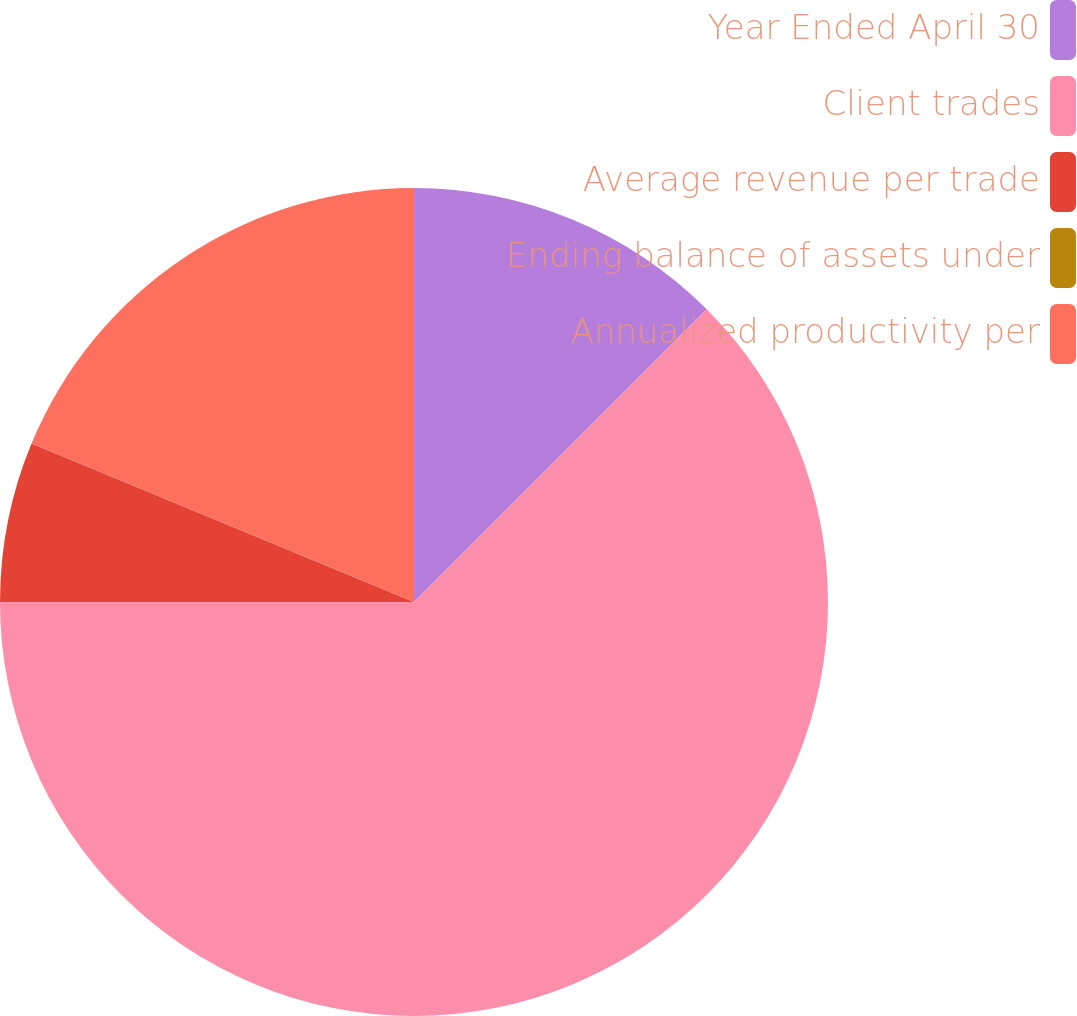Convert chart to OTSL. <chart><loc_0><loc_0><loc_500><loc_500><pie_chart><fcel>Year Ended April 30<fcel>Client trades<fcel>Average revenue per trade<fcel>Ending balance of assets under<fcel>Annualized productivity per<nl><fcel>12.5%<fcel>62.5%<fcel>6.25%<fcel>0.0%<fcel>18.75%<nl></chart> 